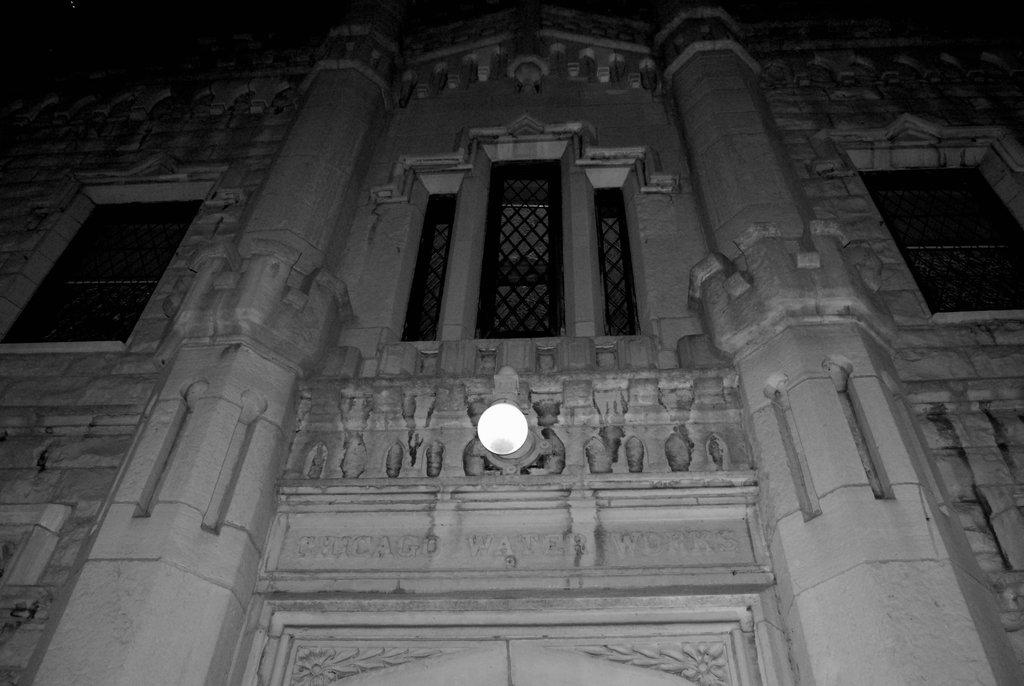What type of image is shown in the picture? The image contains a black and white picture of a building. What architectural features can be seen on the building? The building has windows. Can you describe the lighting conditions in the image? There is light visible in the image. Reasoning: Let' Let's think step by step in order to produce the conversation. We start by identifying the main subject of the image, which is a black and white picture of a building. Next, we describe specific features of the building, such as the windows. Finally, we mention the lighting conditions in the image, which is described as having light visible. Absurd Question/Answer: What type of steel is used to construct the letters in the image? There are no letters present in the image, so it is not possible to determine what type of steel might be used. 